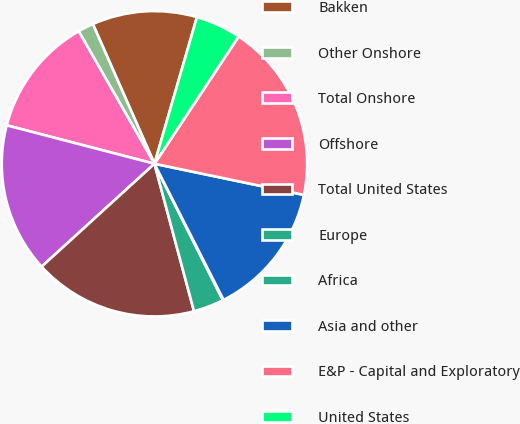Convert chart to OTSL. <chart><loc_0><loc_0><loc_500><loc_500><pie_chart><fcel>Bakken<fcel>Other Onshore<fcel>Total Onshore<fcel>Offshore<fcel>Total United States<fcel>Europe<fcel>Africa<fcel>Asia and other<fcel>E&P - Capital and Exploratory<fcel>United States<nl><fcel>11.1%<fcel>1.66%<fcel>12.68%<fcel>15.82%<fcel>17.4%<fcel>3.23%<fcel>0.08%<fcel>14.25%<fcel>18.97%<fcel>4.81%<nl></chart> 